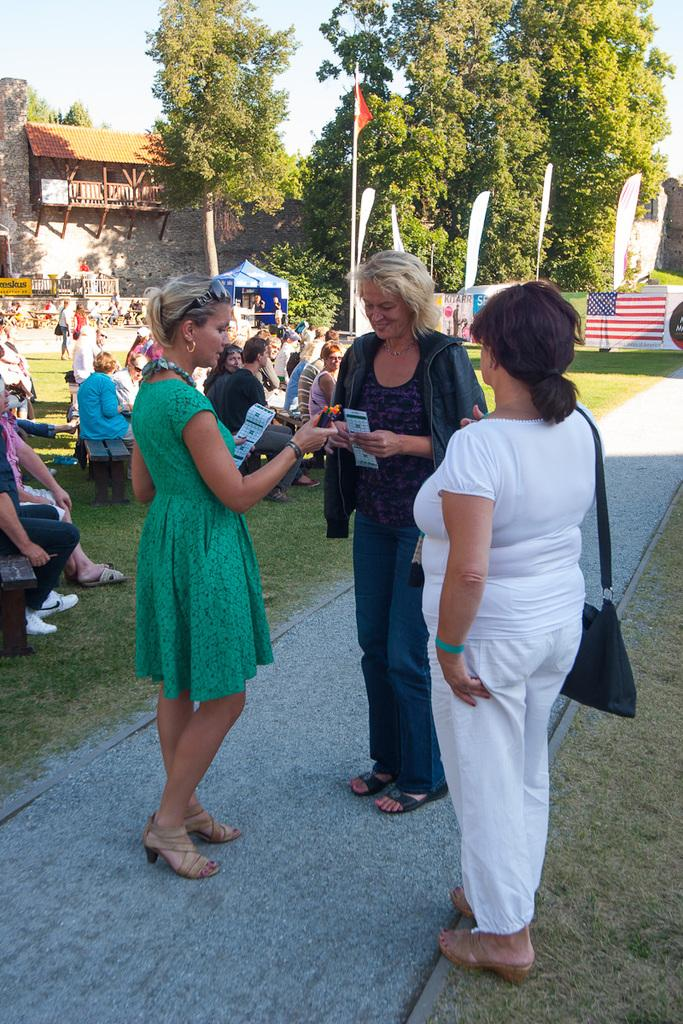What is the main subject in the middle of the image? There is a woman standing in the middle of the image. What is the woman in the middle doing? The woman is smiling. Who else is present in the image? There is another woman on the right side of the image. What is the second woman wearing? The second woman is wearing a white dress. What can be seen in the background of the image? There are trees visible in the background of the image. How many mice can be seen climbing the trees in the background of the image? There are no mice present in the image, and therefore no such activity can be observed. What type of cord is used to hang the second woman's dress in the image? The image does not show any cords or hanging mechanisms for the dress, as it is simply worn by the woman. 